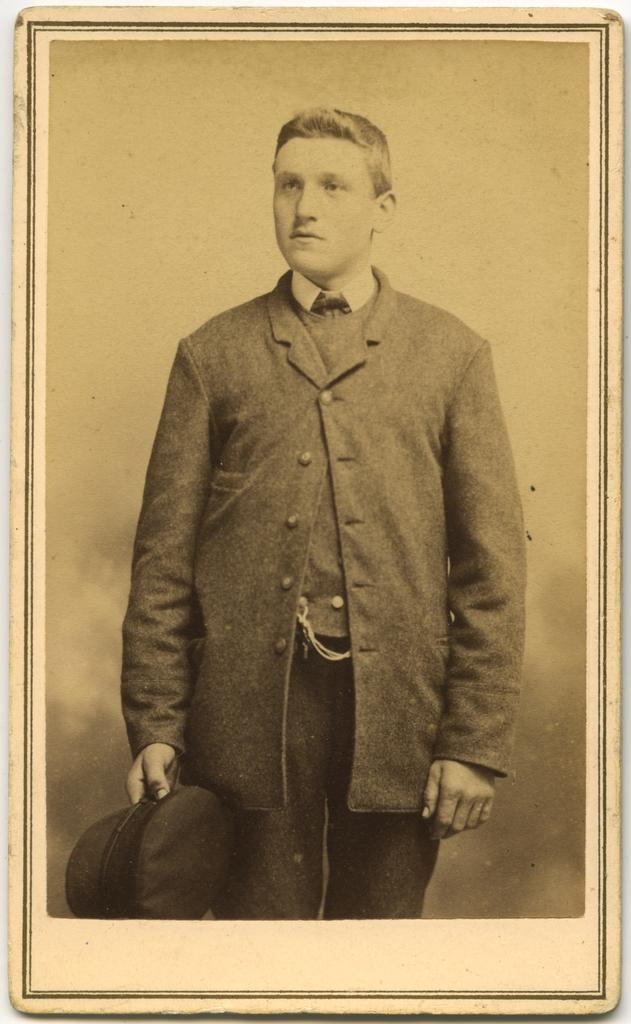What is the main subject of the image? There is a photo in the image. What can be seen in the photo? The photo contains a person. What is the person holding in the photo? The person is holding a cap. What type of cake is being served at the baseball game in the image? There is no cake or baseball game present in the image; it only contains a photo of a person holding a cap. 